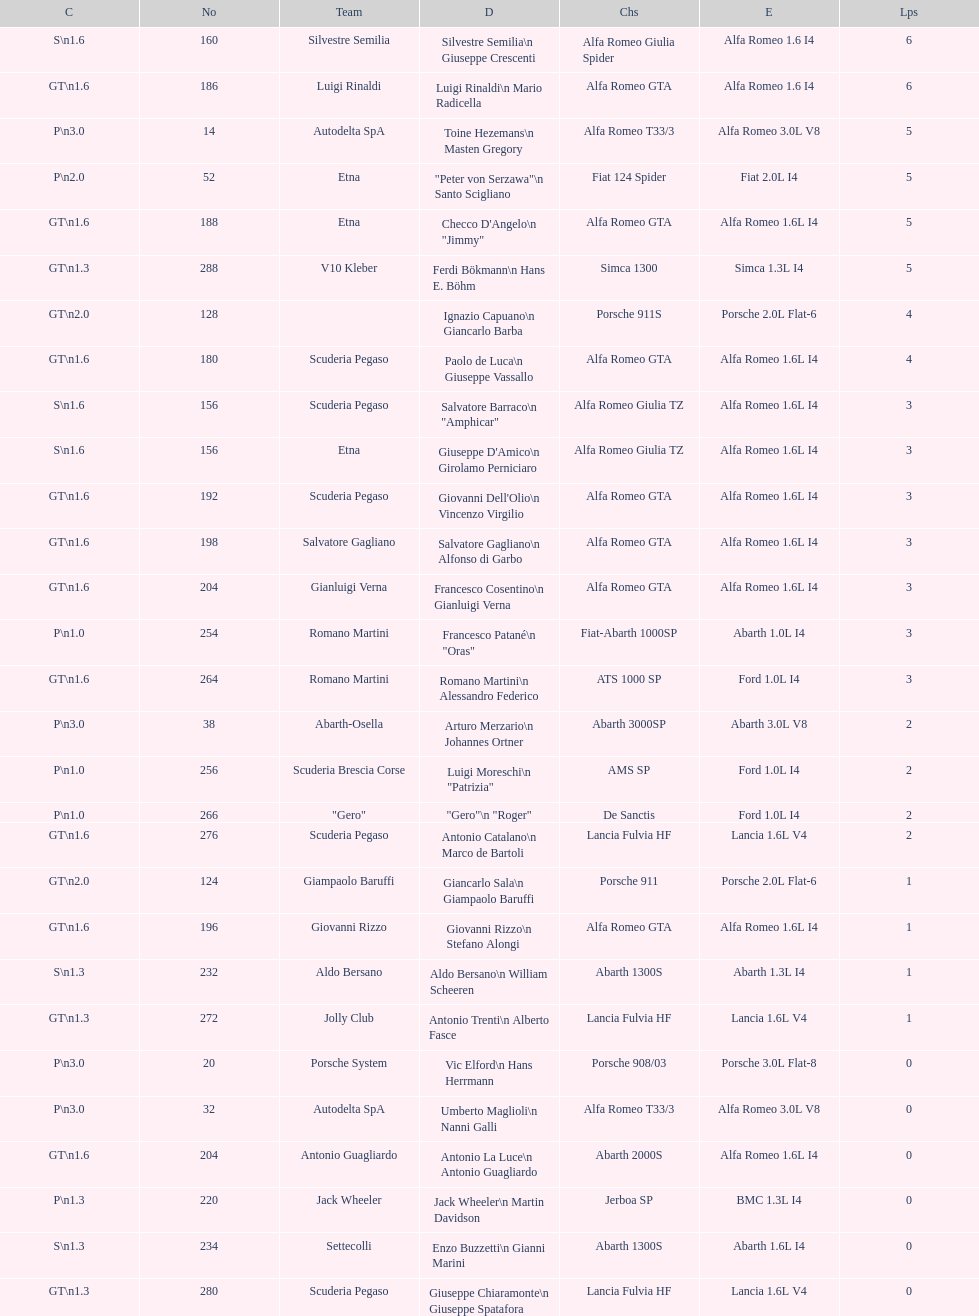How many laps does v10 kleber have? 5. 